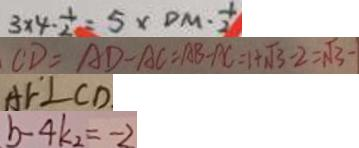Convert formula to latex. <formula><loc_0><loc_0><loc_500><loc_500>3 \times 4 \cdot \frac { 1 } { 2 } = 5 \times D M \cdot \frac { 1 } { 2 } 
 C D = A D - A C = A B - A C = 1 + \sqrt { 3 } - 2 = \sqrt { 3 } - 
 A F \bot C D 
 b - 4 k _ { 2 } = - 2</formula> 